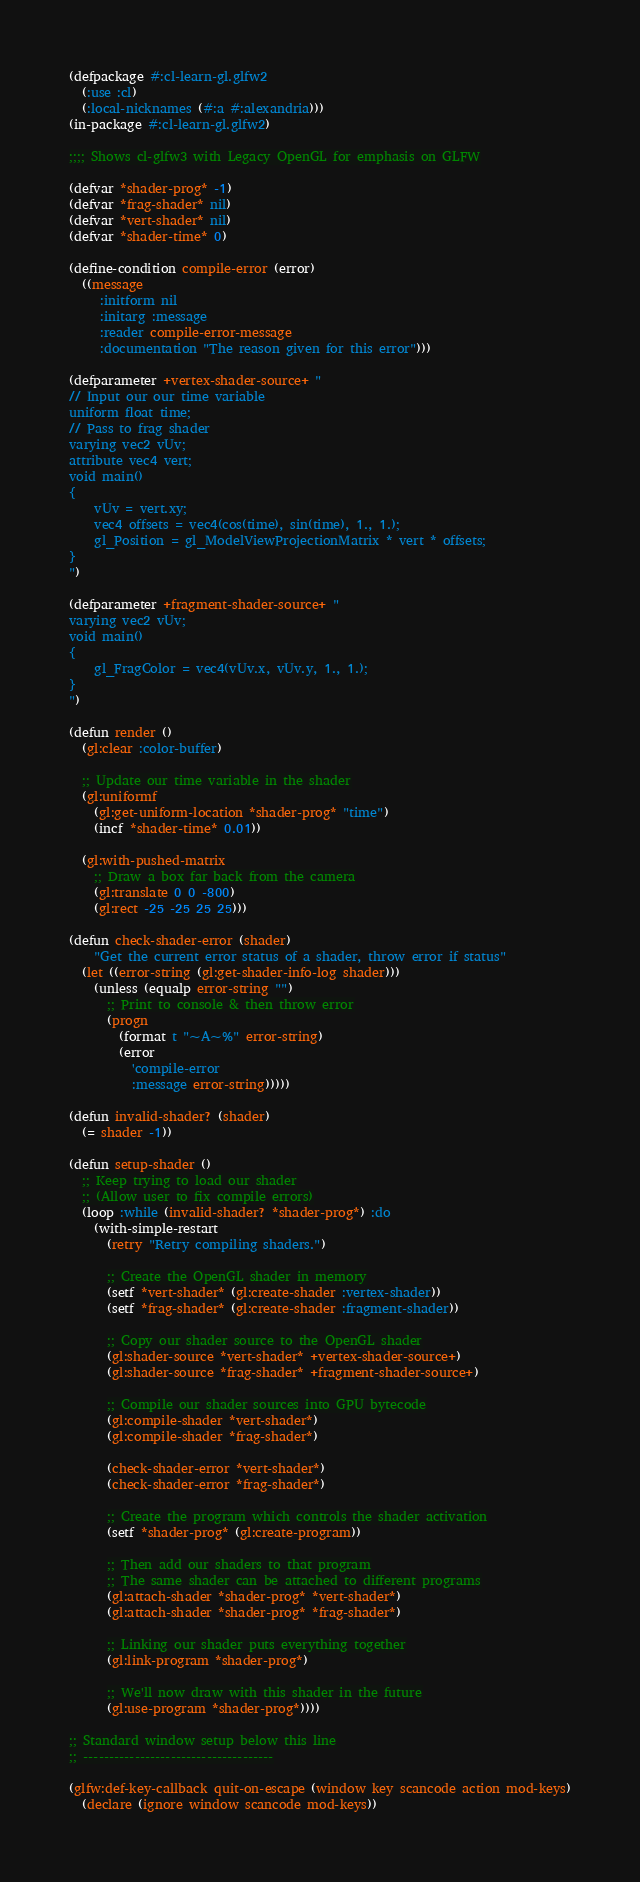Convert code to text. <code><loc_0><loc_0><loc_500><loc_500><_Lisp_>(defpackage #:cl-learn-gl.glfw2
  (:use :cl)
  (:local-nicknames (#:a #:alexandria)))
(in-package #:cl-learn-gl.glfw2)

;;;; Shows cl-glfw3 with Legacy OpenGL for emphasis on GLFW

(defvar *shader-prog* -1)
(defvar *frag-shader* nil)
(defvar *vert-shader* nil)
(defvar *shader-time* 0)

(define-condition compile-error (error)
  ((message
     :initform nil
     :initarg :message
     :reader compile-error-message
     :documentation "The reason given for this error")))

(defparameter +vertex-shader-source+ "
// Input our our time variable
uniform float time;
// Pass to frag shader
varying vec2 vUv;
attribute vec4 vert;
void main()
{
    vUv = vert.xy;
    vec4 offsets = vec4(cos(time), sin(time), 1., 1.);
    gl_Position = gl_ModelViewProjectionMatrix * vert * offsets;
}
")

(defparameter +fragment-shader-source+ "
varying vec2 vUv;
void main()
{
    gl_FragColor = vec4(vUv.x, vUv.y, 1., 1.);
}
")

(defun render ()
  (gl:clear :color-buffer)

  ;; Update our time variable in the shader
  (gl:uniformf
    (gl:get-uniform-location *shader-prog* "time")
    (incf *shader-time* 0.01))

  (gl:with-pushed-matrix
    ;; Draw a box far back from the camera
    (gl:translate 0 0 -800)
    (gl:rect -25 -25 25 25)))

(defun check-shader-error (shader)
    "Get the current error status of a shader, throw error if status"
  (let ((error-string (gl:get-shader-info-log shader)))
    (unless (equalp error-string "")
      ;; Print to console & then throw error
      (progn
        (format t "~A~%" error-string)
        (error
          'compile-error
          :message error-string)))))

(defun invalid-shader? (shader)
  (= shader -1))

(defun setup-shader ()
  ;; Keep trying to load our shader
  ;; (Allow user to fix compile errors)
  (loop :while (invalid-shader? *shader-prog*) :do
    (with-simple-restart
      (retry "Retry compiling shaders.")

      ;; Create the OpenGL shader in memory
      (setf *vert-shader* (gl:create-shader :vertex-shader))
      (setf *frag-shader* (gl:create-shader :fragment-shader))

      ;; Copy our shader source to the OpenGL shader
      (gl:shader-source *vert-shader* +vertex-shader-source+)
      (gl:shader-source *frag-shader* +fragment-shader-source+)

      ;; Compile our shader sources into GPU bytecode
      (gl:compile-shader *vert-shader*)
      (gl:compile-shader *frag-shader*)

      (check-shader-error *vert-shader*)
      (check-shader-error *frag-shader*)

      ;; Create the program which controls the shader activation
      (setf *shader-prog* (gl:create-program))

      ;; Then add our shaders to that program
      ;; The same shader can be attached to different programs
      (gl:attach-shader *shader-prog* *vert-shader*)
      (gl:attach-shader *shader-prog* *frag-shader*)

      ;; Linking our shader puts everything together
      (gl:link-program *shader-prog*)

      ;; We'll now draw with this shader in the future
      (gl:use-program *shader-prog*))))

;; Standard window setup below this line
;; -------------------------------------

(glfw:def-key-callback quit-on-escape (window key scancode action mod-keys)
  (declare (ignore window scancode mod-keys))</code> 